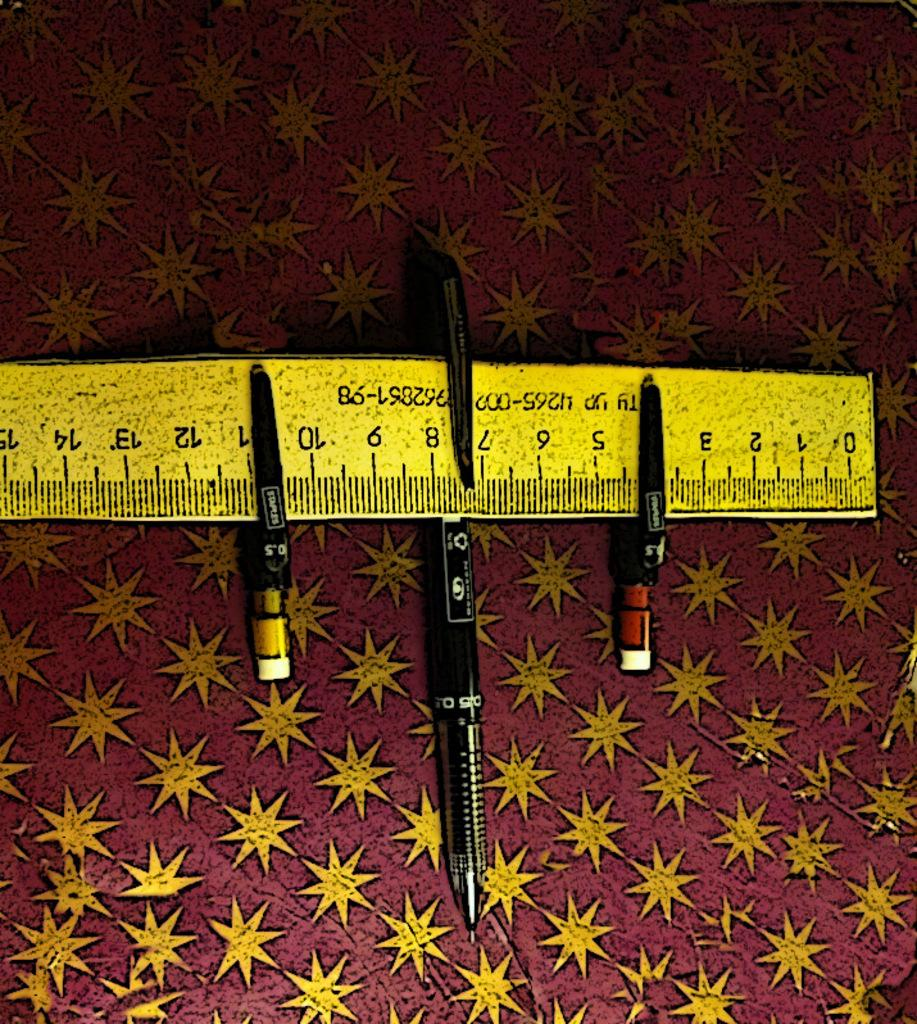Provide a one-sentence caption for the provided image. Three pens are attached to a ruler, one of them at the 4 cm mark. 